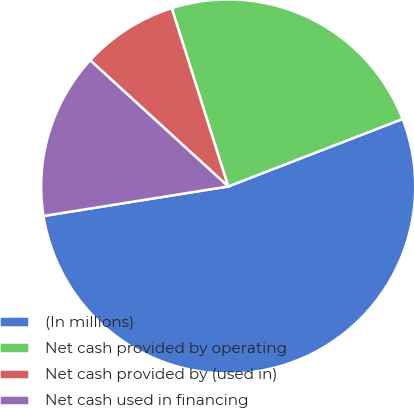<chart> <loc_0><loc_0><loc_500><loc_500><pie_chart><fcel>(In millions)<fcel>Net cash provided by operating<fcel>Net cash provided by (used in)<fcel>Net cash used in financing<nl><fcel>53.35%<fcel>24.0%<fcel>8.33%<fcel>14.31%<nl></chart> 